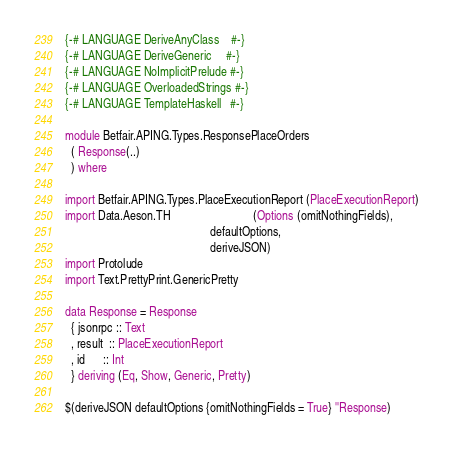Convert code to text. <code><loc_0><loc_0><loc_500><loc_500><_Haskell_>{-# LANGUAGE DeriveAnyClass    #-}
{-# LANGUAGE DeriveGeneric     #-}
{-# LANGUAGE NoImplicitPrelude #-}
{-# LANGUAGE OverloadedStrings #-}
{-# LANGUAGE TemplateHaskell   #-}

module Betfair.APING.Types.ResponsePlaceOrders
  ( Response(..)
  ) where

import Betfair.APING.Types.PlaceExecutionReport (PlaceExecutionReport)
import Data.Aeson.TH                            (Options (omitNothingFields),
                                                 defaultOptions,
                                                 deriveJSON)
import Protolude
import Text.PrettyPrint.GenericPretty

data Response = Response
  { jsonrpc :: Text
  , result  :: PlaceExecutionReport
  , id      :: Int
  } deriving (Eq, Show, Generic, Pretty)

$(deriveJSON defaultOptions {omitNothingFields = True} ''Response)
</code> 